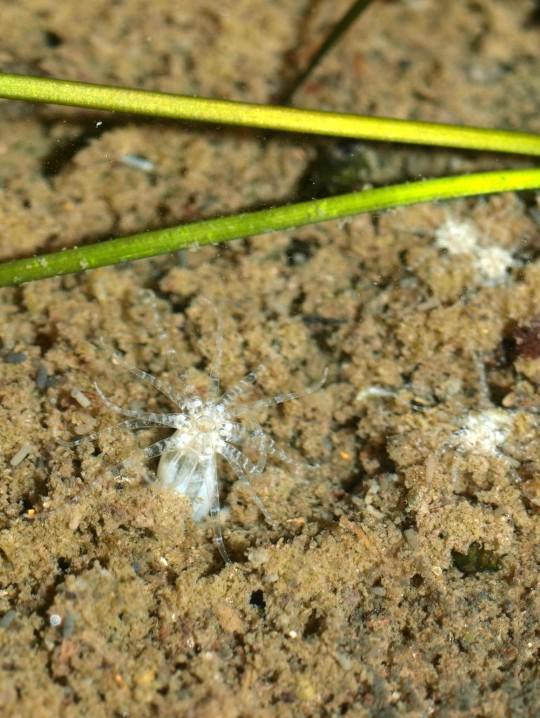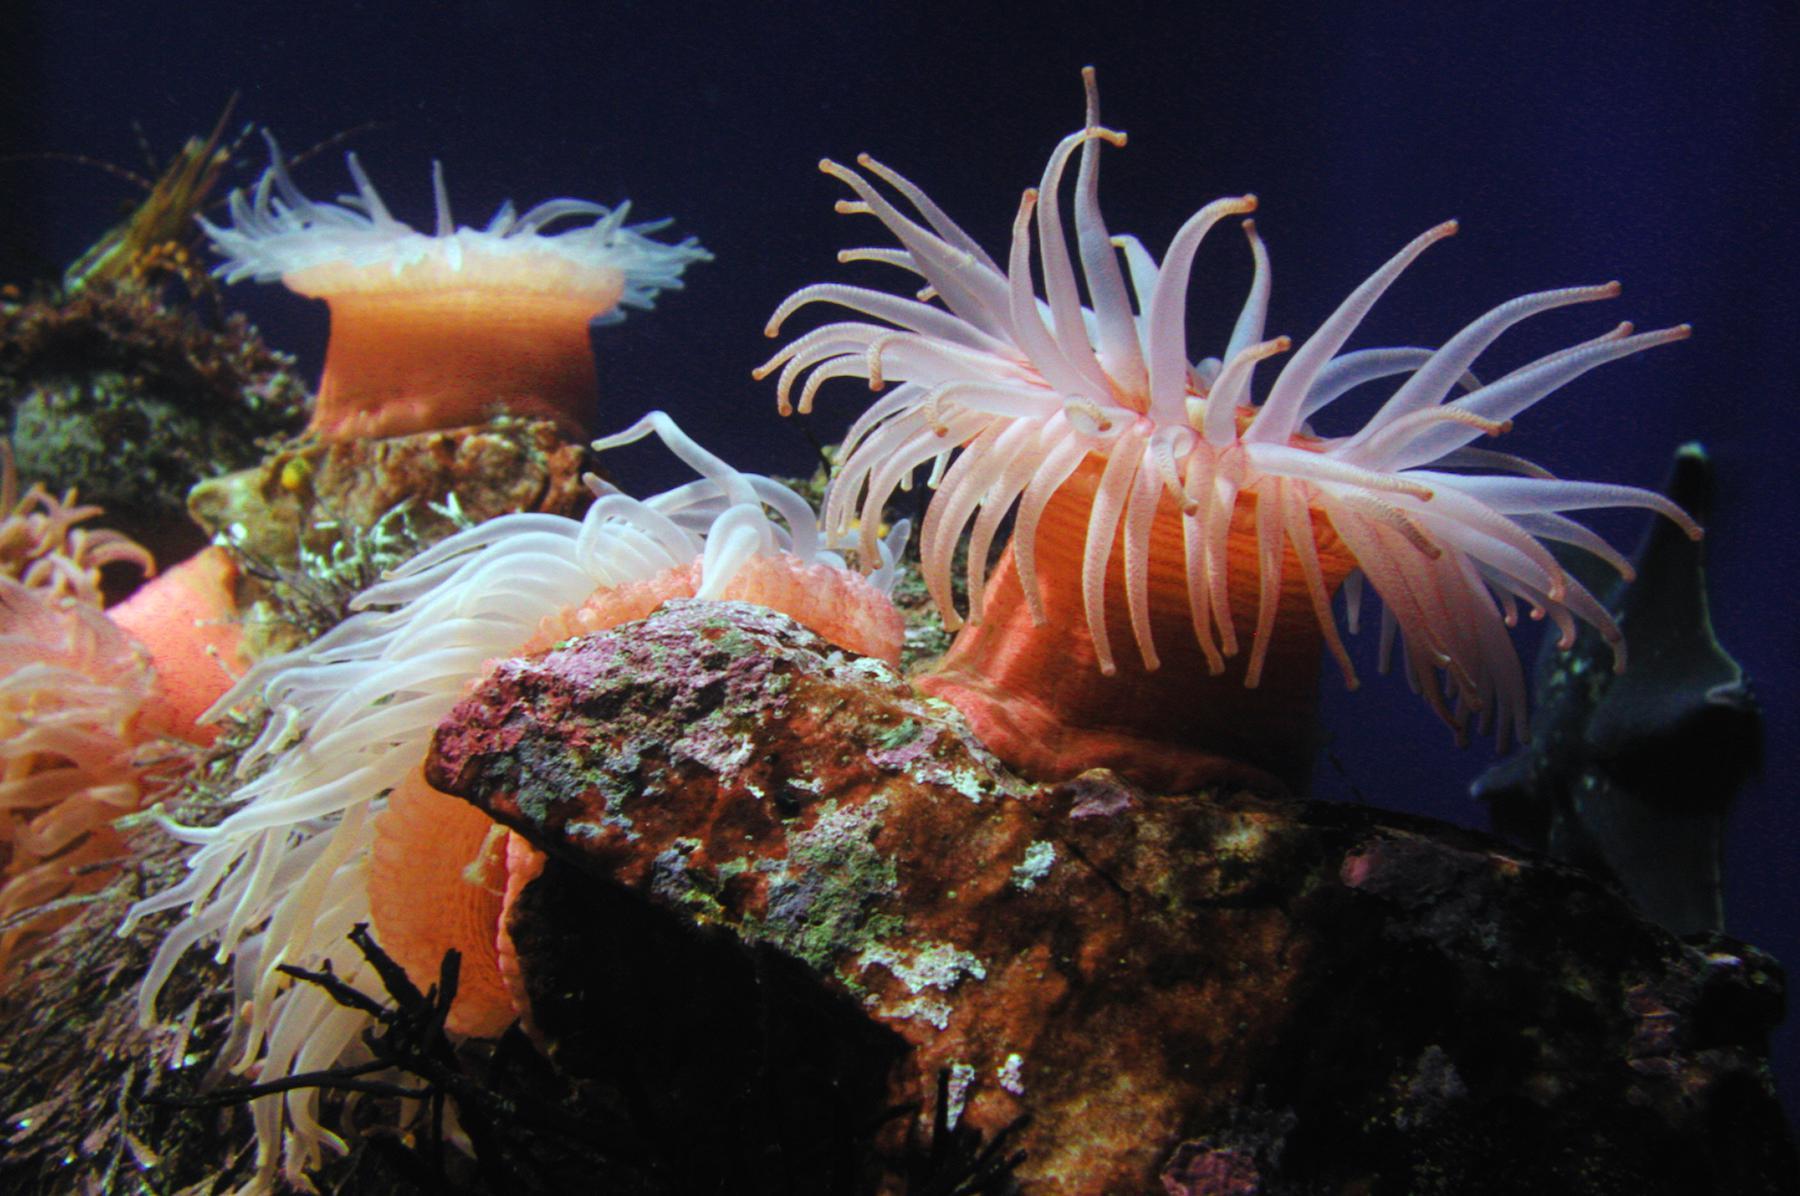The first image is the image on the left, the second image is the image on the right. Assess this claim about the two images: "Each image shows only a single living organism.". Correct or not? Answer yes or no. No. The first image is the image on the left, the second image is the image on the right. Examine the images to the left and right. Is the description "An image shows at least one anemone with tapering tendrils that has its stalk on a rock-like surface." accurate? Answer yes or no. Yes. 